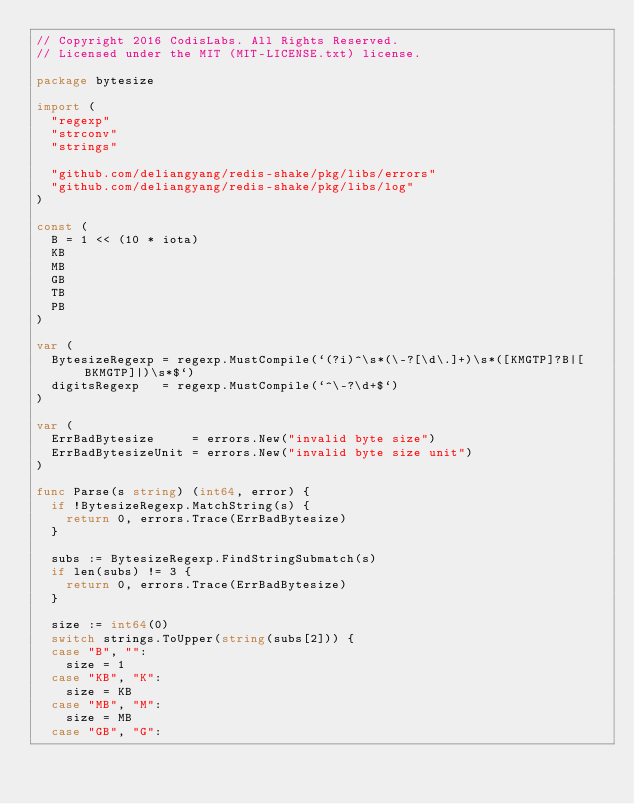Convert code to text. <code><loc_0><loc_0><loc_500><loc_500><_Go_>// Copyright 2016 CodisLabs. All Rights Reserved.
// Licensed under the MIT (MIT-LICENSE.txt) license.

package bytesize

import (
	"regexp"
	"strconv"
	"strings"

	"github.com/deliangyang/redis-shake/pkg/libs/errors"
	"github.com/deliangyang/redis-shake/pkg/libs/log"
)

const (
	B = 1 << (10 * iota)
	KB
	MB
	GB
	TB
	PB
)

var (
	BytesizeRegexp = regexp.MustCompile(`(?i)^\s*(\-?[\d\.]+)\s*([KMGTP]?B|[BKMGTP]|)\s*$`)
	digitsRegexp   = regexp.MustCompile(`^\-?\d+$`)
)

var (
	ErrBadBytesize     = errors.New("invalid byte size")
	ErrBadBytesizeUnit = errors.New("invalid byte size unit")
)

func Parse(s string) (int64, error) {
	if !BytesizeRegexp.MatchString(s) {
		return 0, errors.Trace(ErrBadBytesize)
	}

	subs := BytesizeRegexp.FindStringSubmatch(s)
	if len(subs) != 3 {
		return 0, errors.Trace(ErrBadBytesize)
	}

	size := int64(0)
	switch strings.ToUpper(string(subs[2])) {
	case "B", "":
		size = 1
	case "KB", "K":
		size = KB
	case "MB", "M":
		size = MB
	case "GB", "G":</code> 